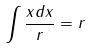Convert formula to latex. <formula><loc_0><loc_0><loc_500><loc_500>\int \frac { x d x } { r } = r</formula> 